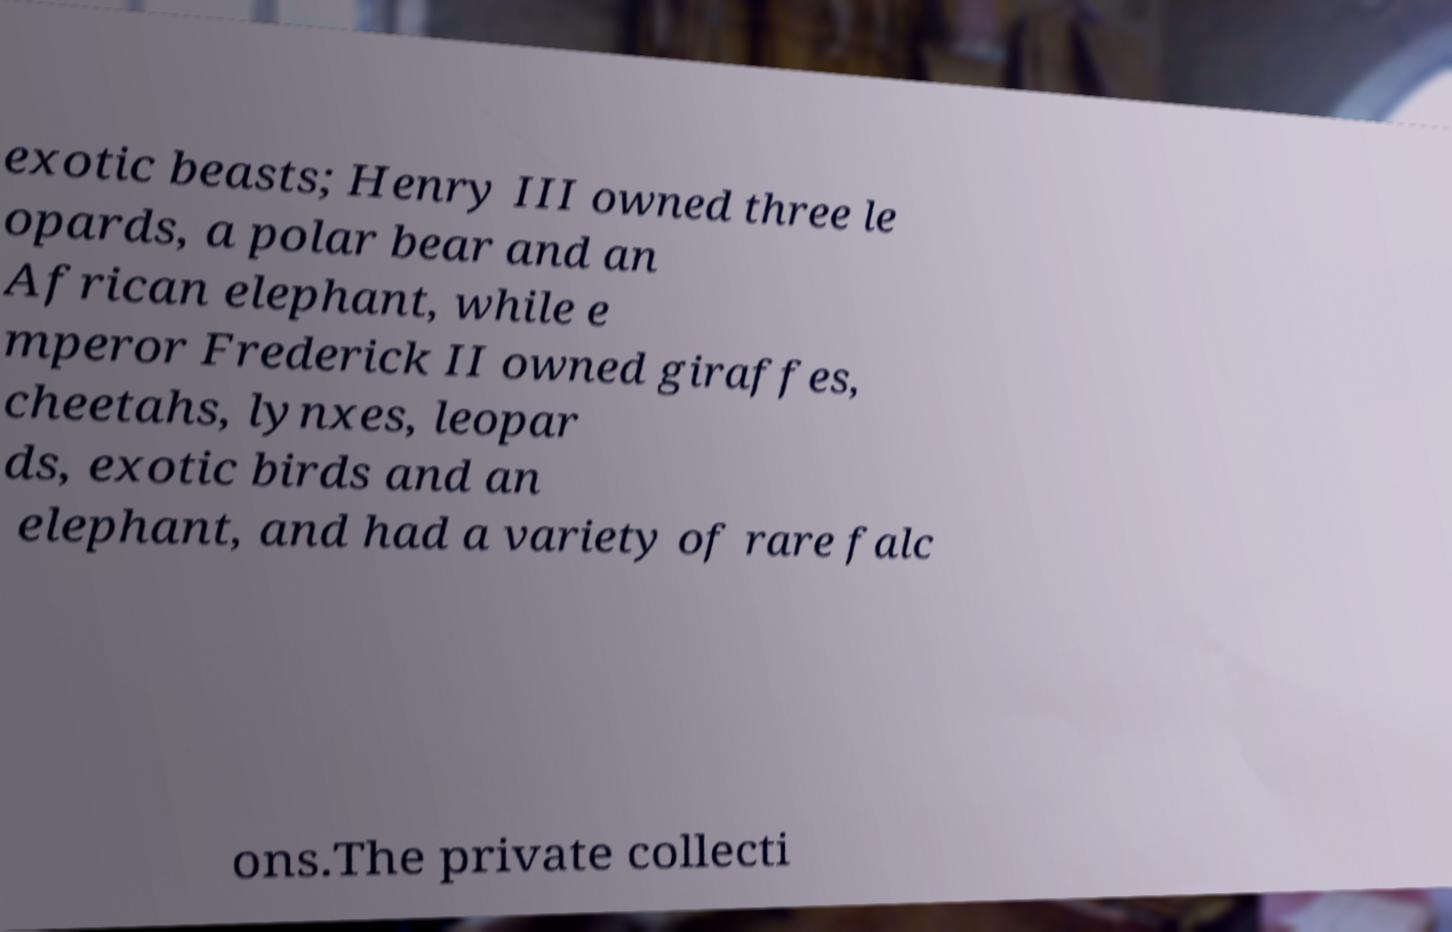I need the written content from this picture converted into text. Can you do that? exotic beasts; Henry III owned three le opards, a polar bear and an African elephant, while e mperor Frederick II owned giraffes, cheetahs, lynxes, leopar ds, exotic birds and an elephant, and had a variety of rare falc ons.The private collecti 